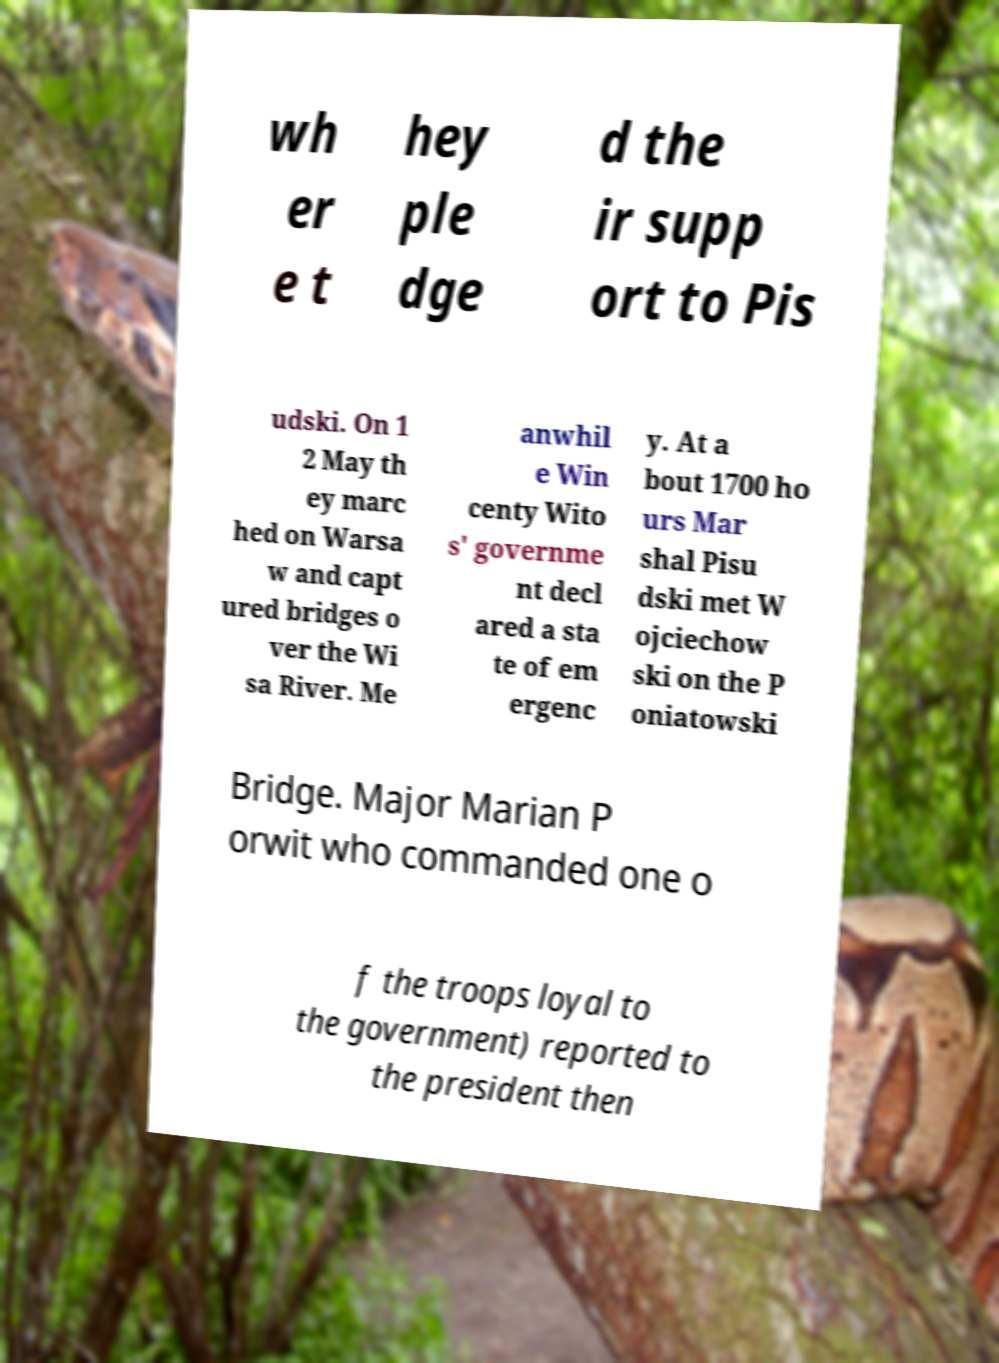There's text embedded in this image that I need extracted. Can you transcribe it verbatim? wh er e t hey ple dge d the ir supp ort to Pis udski. On 1 2 May th ey marc hed on Warsa w and capt ured bridges o ver the Wi sa River. Me anwhil e Win centy Wito s' governme nt decl ared a sta te of em ergenc y. At a bout 1700 ho urs Mar shal Pisu dski met W ojciechow ski on the P oniatowski Bridge. Major Marian P orwit who commanded one o f the troops loyal to the government) reported to the president then 